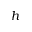Convert formula to latex. <formula><loc_0><loc_0><loc_500><loc_500>h</formula> 